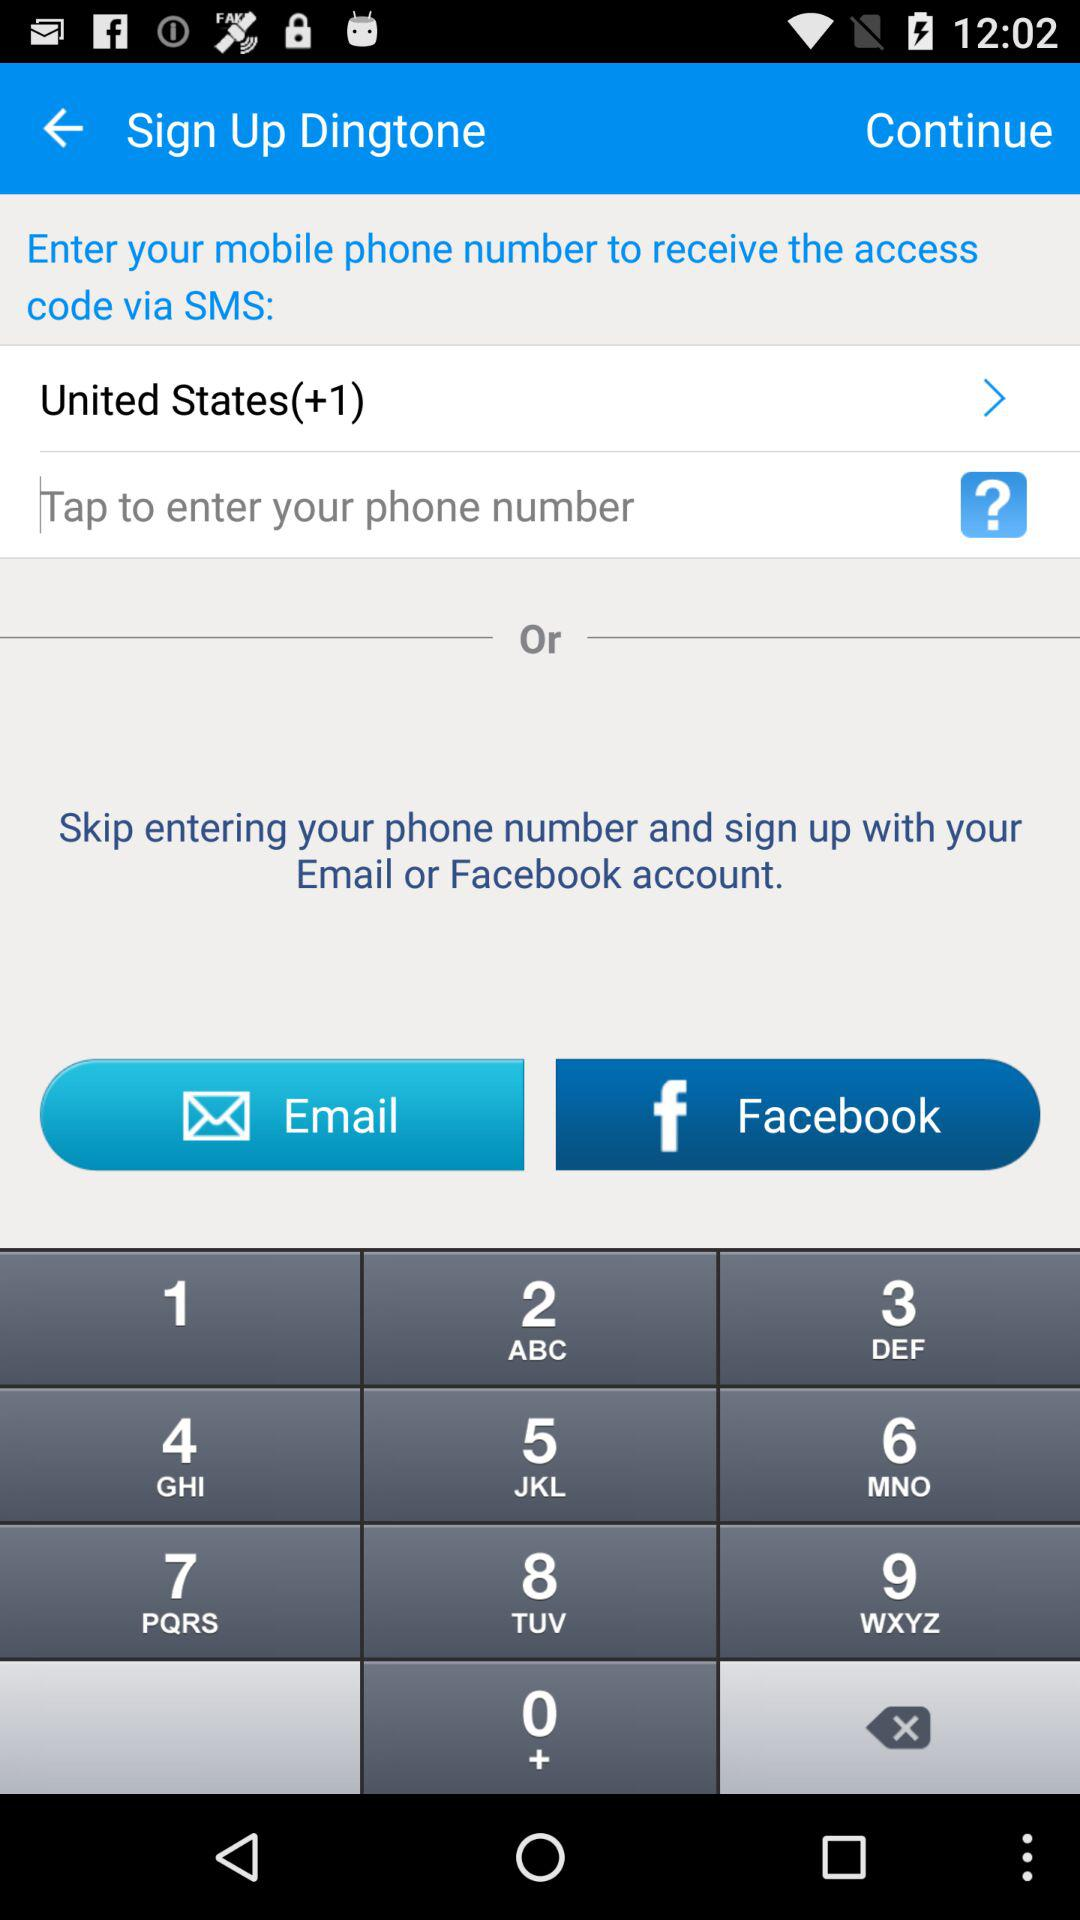What accounts can I use to sign up? You can use "Email" and "Facebook" accounts to sign up. 